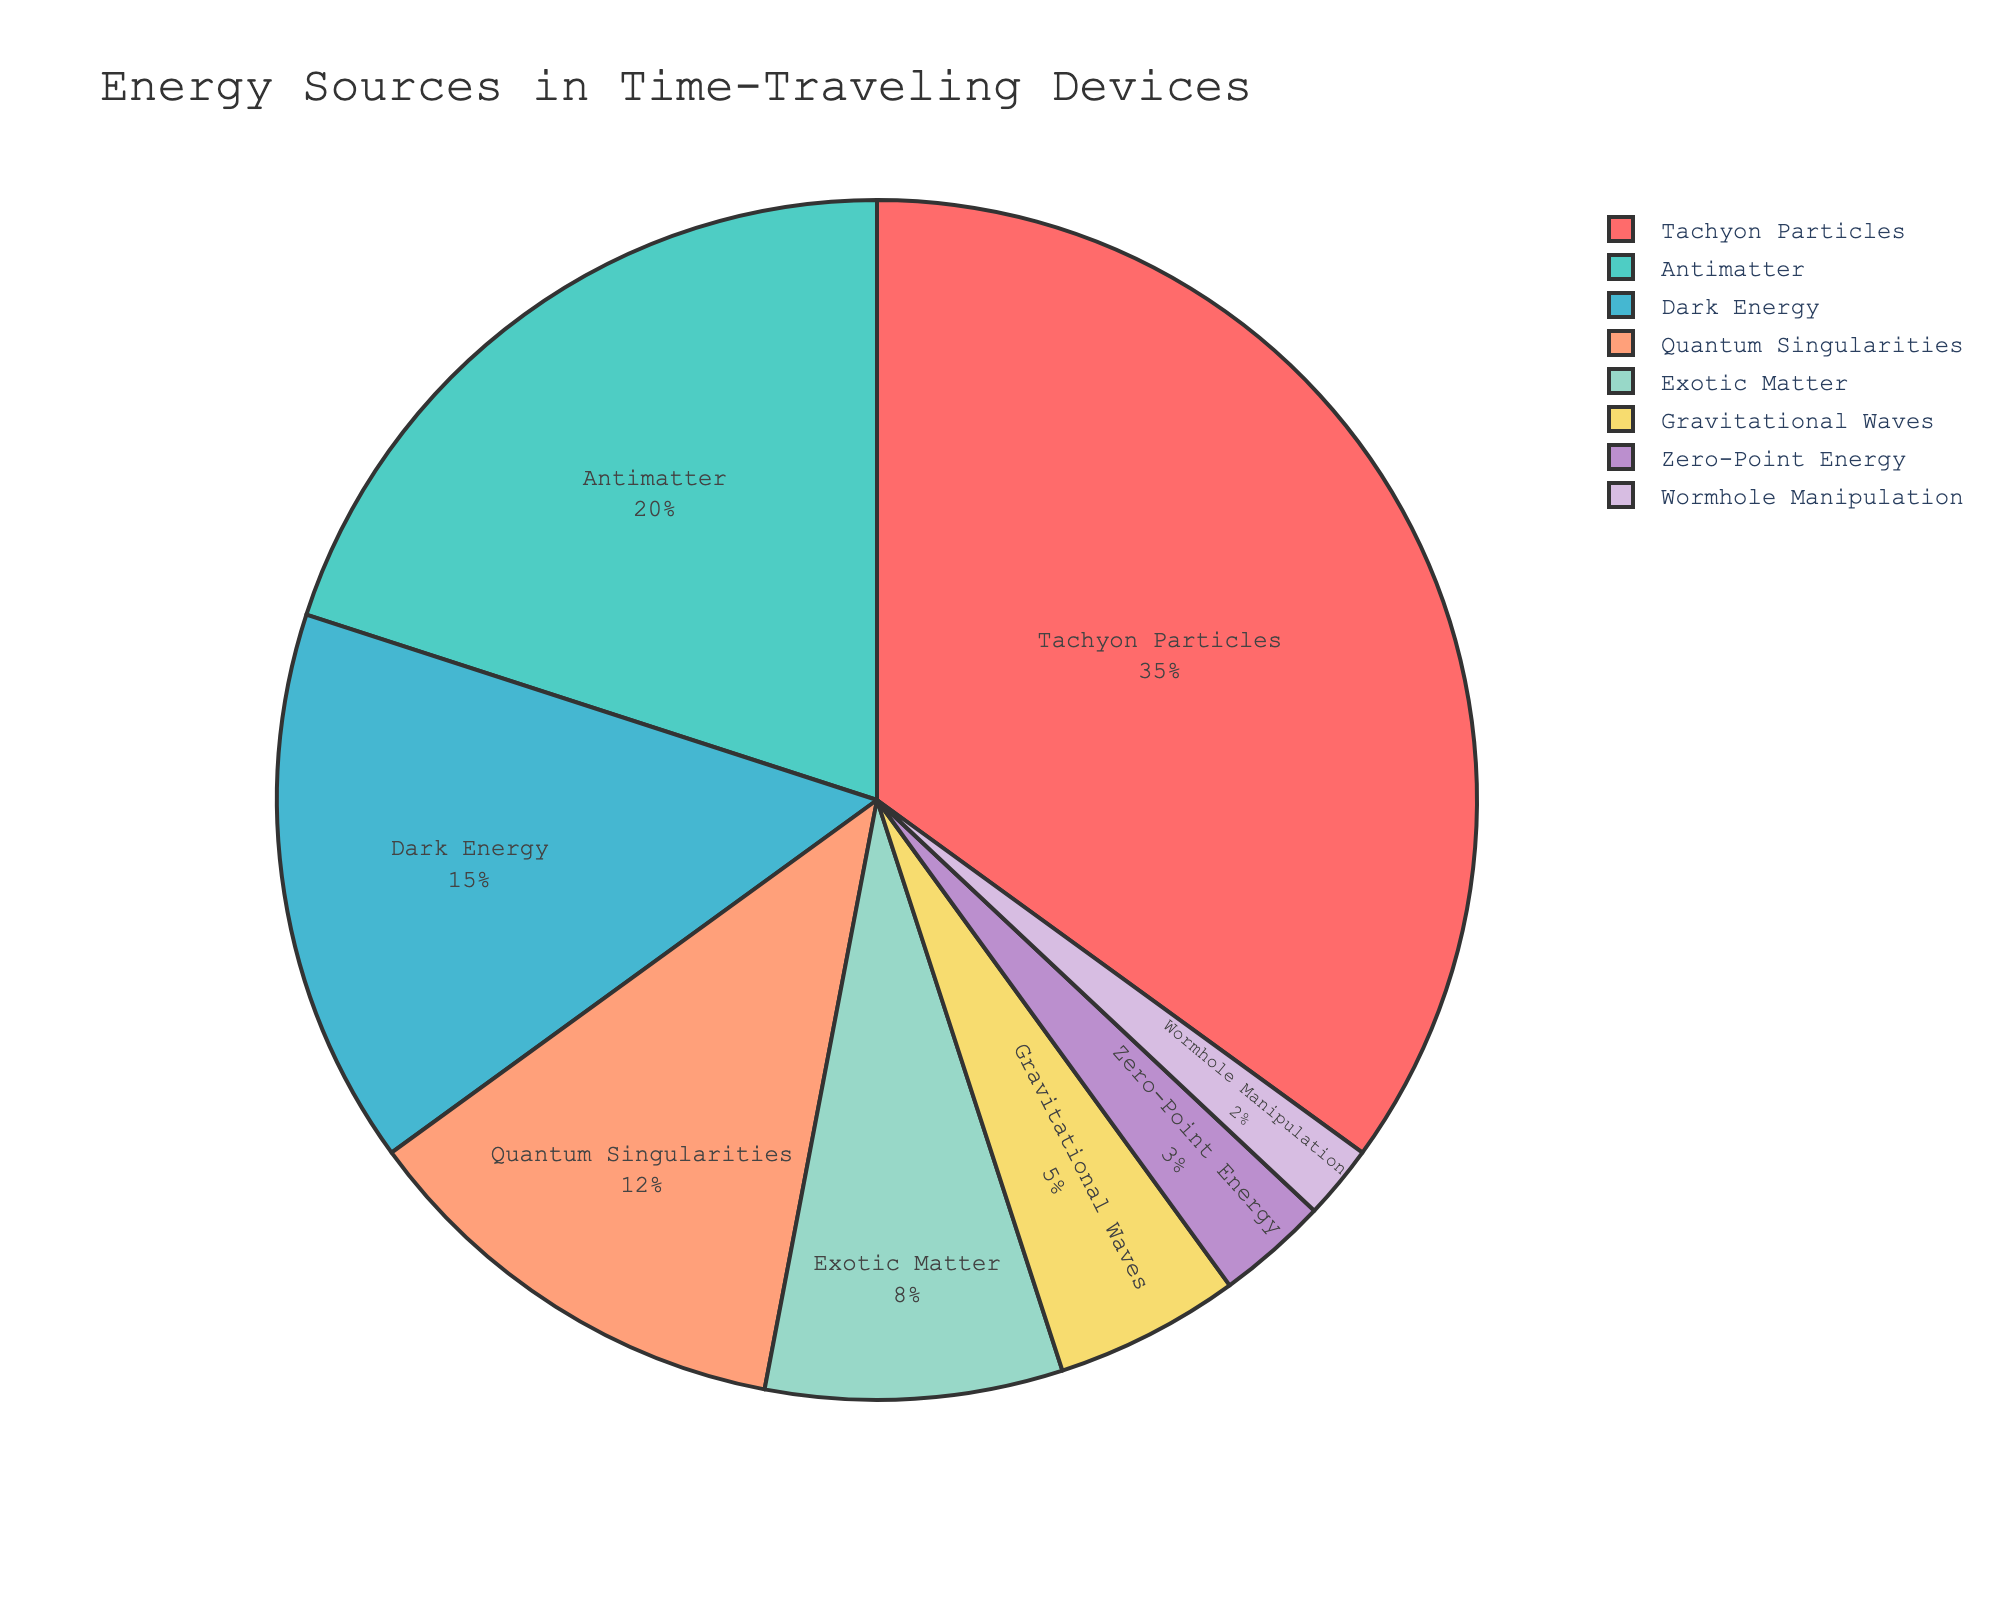What's the most prevalent energy source used in time-traveling devices? The pie chart shows the breakdown of different energy sources. The largest section, representing the highest percentage, is labeled "Tachyon Particles" with 35%.
Answer: Tachyon Particles Which energy source has the smallest percentage usage, and what's the percentage? By looking at the pie chart, the smallest section belongs to "Wormhole Manipulation" and is labeled with a 2% usage.
Answer: Wormhole Manipulation, 2% How much more significant is the contribution of Tachyon Particles compared to Gravitational Waves? To find this, subtract the percentage of Gravitational Waves from Tachyon Particles: 35% (Tachyon Particles) - 5% (Gravitational Waves) = 30%.
Answer: 30% What's the combined percentage of Antimatter and Dark Energy sources? Add the percentages of Antimatter (20%) and Dark Energy (15%): 20% + 15% = 35%.
Answer: 35% Which energy sources together make up exactly half of the total energy source percentages used? By adding the percentages step-by-step, we find:
1. Tachyon Particles (35%) + Antimatter (20%) = 55% (too much)
2. Antimatter (20%) + Dark Energy (15%) + Quantum Singularities (12%) + Exotic Matter (8%) = 55% (too much)
3. Removing Antimatter - Dark Energy (15%) + Quantum Singularities (12%) + Exotic Matter (8%) = 35% (too low)
The ones adding up properly are Antimatter, Dark Energy, Quantum Singularities, and Exotic Matter.
Answer: Antimatter and Dark Energy If the energy sources Antimatter and Exotic Matter were combined into a single category, what would be the new percentage for this combined category? Add the percentages of Antimatter (20%) and Exotic Matter (8%): 20% + 8% = 28%.
Answer: 28% Are there more energy sources with a percentage above 10% or below 10%? Count data points above 10%: Tachyon Particles (35%), Antimatter (20%), Dark Energy (15%), Quantum Singularities (12%) – 4 sources. Count data points below 10%: Exotic Matter (8%), Gravitational Waves (5%), Zero-Point Energy (3%), Wormhole Manipulation (2%) – 4 sources. Both are equal in number.
Answer: Equal How does the percentage usage of Quantum Singularities compare to Dark Energy? Quantum Singularities have a 12% usage, while Dark Energy has a 15% usage. Since 12% is less than 15%, Quantum Singularities are used less.
Answer: Less What's the difference in percentage between the highest and lowest-used energy source? The highest-used energy source is Tachyon Particles at 35%, and the lowest-used is Wormhole Manipulation at 2%. The difference is 35% - 2% = 33%.
Answer: 33% Which energy source's segment appears in light-blue color on the pie chart? According to the color palette used, Antimatter is designated by the light-blue color.
Answer: Antimatter 